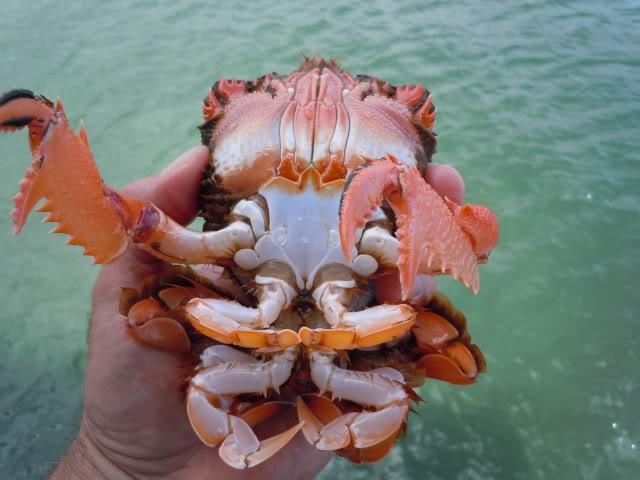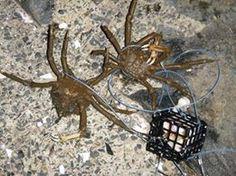The first image is the image on the left, the second image is the image on the right. Evaluate the accuracy of this statement regarding the images: "One image contains at least one human hand, and the other image includes some crabs and a box formed of a grid of box shapes.". Is it true? Answer yes or no. Yes. 